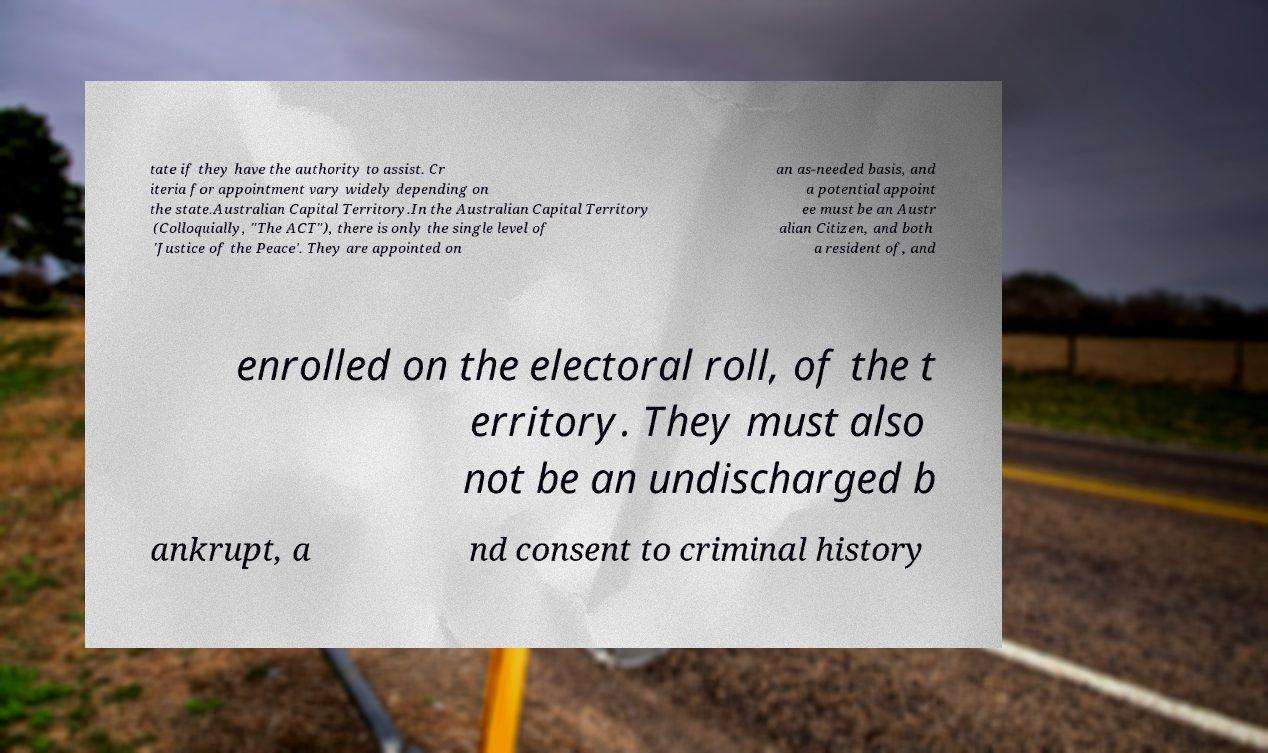I need the written content from this picture converted into text. Can you do that? tate if they have the authority to assist. Cr iteria for appointment vary widely depending on the state.Australian Capital Territory.In the Australian Capital Territory (Colloquially, "The ACT"), there is only the single level of 'Justice of the Peace'. They are appointed on an as-needed basis, and a potential appoint ee must be an Austr alian Citizen, and both a resident of, and enrolled on the electoral roll, of the t erritory. They must also not be an undischarged b ankrupt, a nd consent to criminal history 